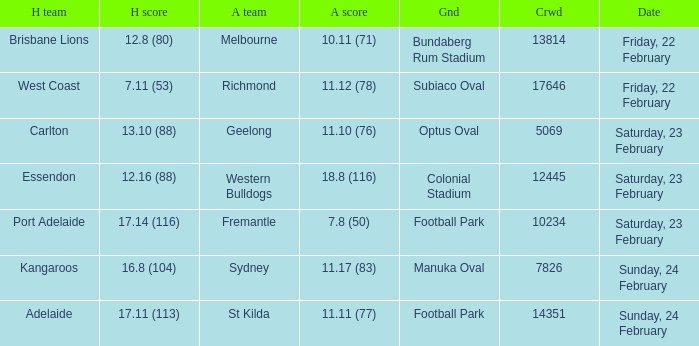Where the home team scored 13.10 (88), what was the size of the crowd? 5069.0. Could you help me parse every detail presented in this table? {'header': ['H team', 'H score', 'A team', 'A score', 'Gnd', 'Crwd', 'Date'], 'rows': [['Brisbane Lions', '12.8 (80)', 'Melbourne', '10.11 (71)', 'Bundaberg Rum Stadium', '13814', 'Friday, 22 February'], ['West Coast', '7.11 (53)', 'Richmond', '11.12 (78)', 'Subiaco Oval', '17646', 'Friday, 22 February'], ['Carlton', '13.10 (88)', 'Geelong', '11.10 (76)', 'Optus Oval', '5069', 'Saturday, 23 February'], ['Essendon', '12.16 (88)', 'Western Bulldogs', '18.8 (116)', 'Colonial Stadium', '12445', 'Saturday, 23 February'], ['Port Adelaide', '17.14 (116)', 'Fremantle', '7.8 (50)', 'Football Park', '10234', 'Saturday, 23 February'], ['Kangaroos', '16.8 (104)', 'Sydney', '11.17 (83)', 'Manuka Oval', '7826', 'Sunday, 24 February'], ['Adelaide', '17.11 (113)', 'St Kilda', '11.11 (77)', 'Football Park', '14351', 'Sunday, 24 February']]} 